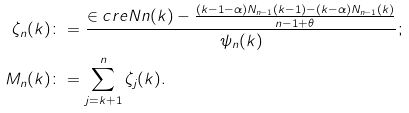<formula> <loc_0><loc_0><loc_500><loc_500>\zeta _ { n } ( k ) & \colon = \frac { \in c r e { N } { n } ( k ) - \frac { ( k - 1 - \alpha ) N _ { n - 1 } ( k - 1 ) - ( k - \alpha ) N _ { n - 1 } ( k ) } { n - 1 + \theta } } { \psi _ { n } ( k ) } ; \\ M _ { n } ( k ) & \colon = \sum _ { j = k + 1 } ^ { n } \zeta _ { j } ( k ) .</formula> 